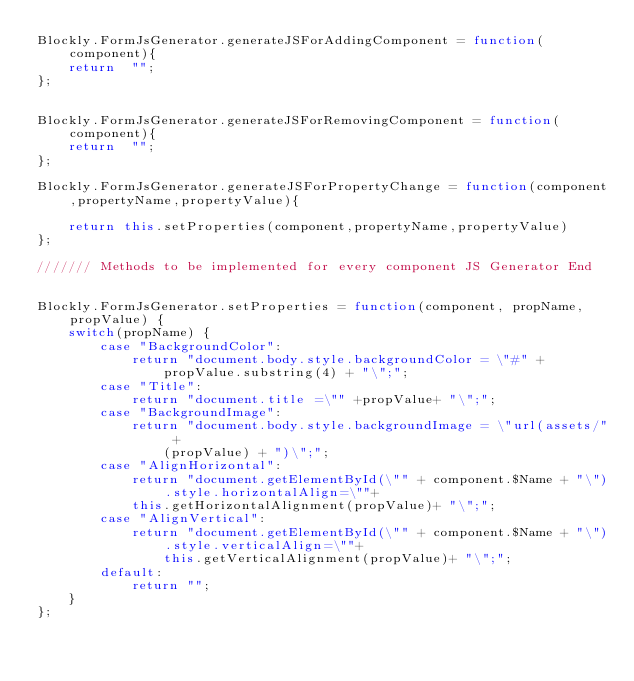Convert code to text. <code><loc_0><loc_0><loc_500><loc_500><_JavaScript_>Blockly.FormJsGenerator.generateJSForAddingComponent = function(component){
    return  "";
};


Blockly.FormJsGenerator.generateJSForRemovingComponent = function(component){
    return  "";
};

Blockly.FormJsGenerator.generateJSForPropertyChange = function(component,propertyName,propertyValue){

    return this.setProperties(component,propertyName,propertyValue)
};

/////// Methods to be implemented for every component JS Generator End


Blockly.FormJsGenerator.setProperties = function(component, propName, propValue) {
    switch(propName) {
        case "BackgroundColor":
            return "document.body.style.backgroundColor = \"#" +
                propValue.substring(4) + "\";";
        case "Title":
            return "document.title =\"" +propValue+ "\";";
        case "BackgroundImage":
            return "document.body.style.backgroundImage = \"url(assets/" +
                (propValue) + ")\";";
        case "AlignHorizontal":
            return "document.getElementById(\"" + component.$Name + "\").style.horizontalAlign=\""+
            this.getHorizontalAlignment(propValue)+ "\";";
        case "AlignVertical":
            return "document.getElementById(\"" + component.$Name + "\").style.verticalAlign=\""+
                this.getVerticalAlignment(propValue)+ "\";";
        default:
            return "";
    }
};
</code> 